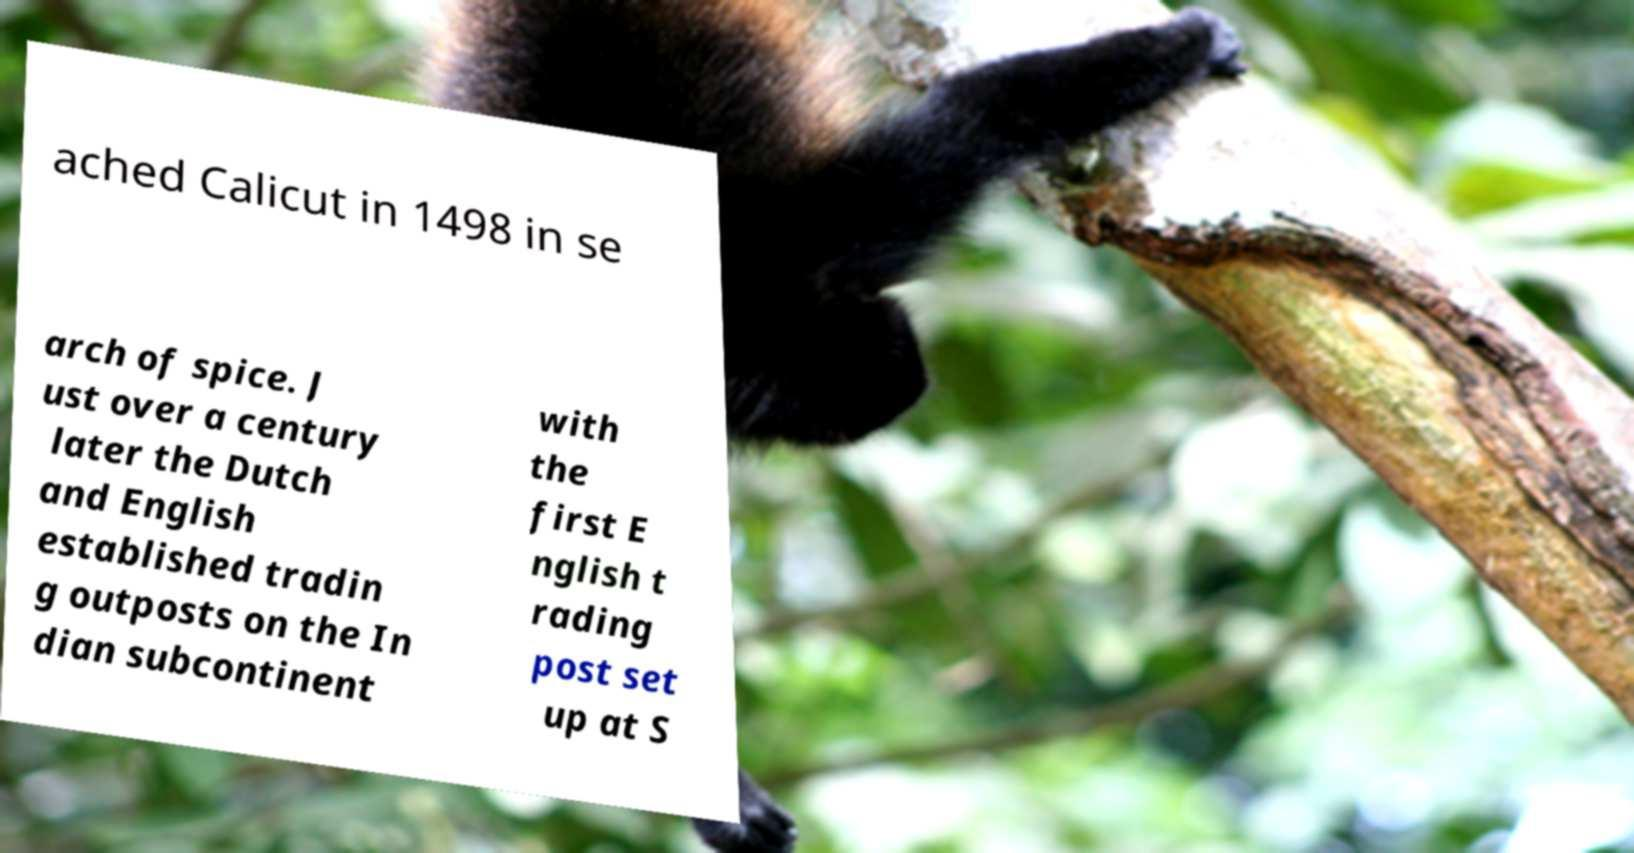Can you read and provide the text displayed in the image?This photo seems to have some interesting text. Can you extract and type it out for me? ached Calicut in 1498 in se arch of spice. J ust over a century later the Dutch and English established tradin g outposts on the In dian subcontinent with the first E nglish t rading post set up at S 